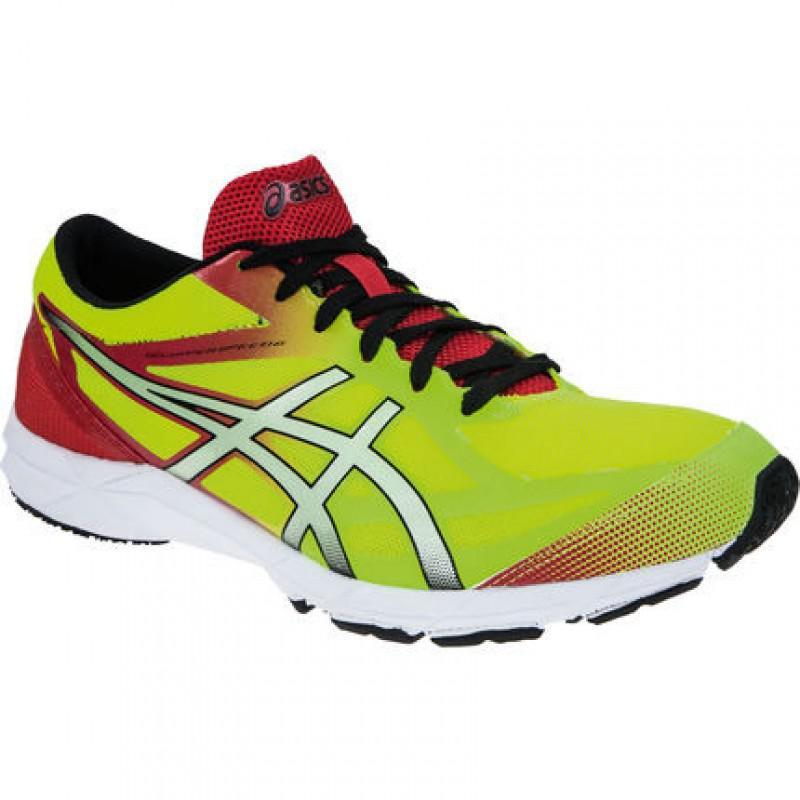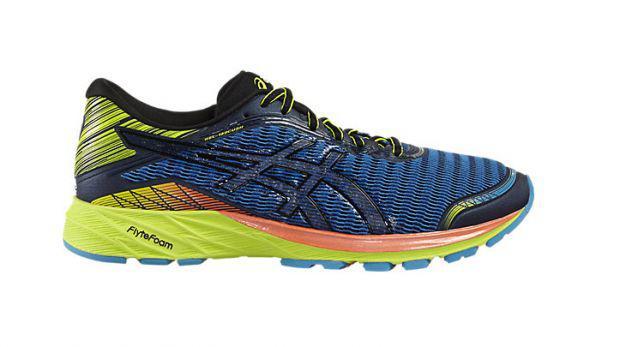The first image is the image on the left, the second image is the image on the right. Given the left and right images, does the statement "Each image shows a single sneaker, and right and left images are posed heel to heel." hold true? Answer yes or no. No. The first image is the image on the left, the second image is the image on the right. Considering the images on both sides, is "The left image contains a sports show who's toe is facing towards the right." valid? Answer yes or no. Yes. 